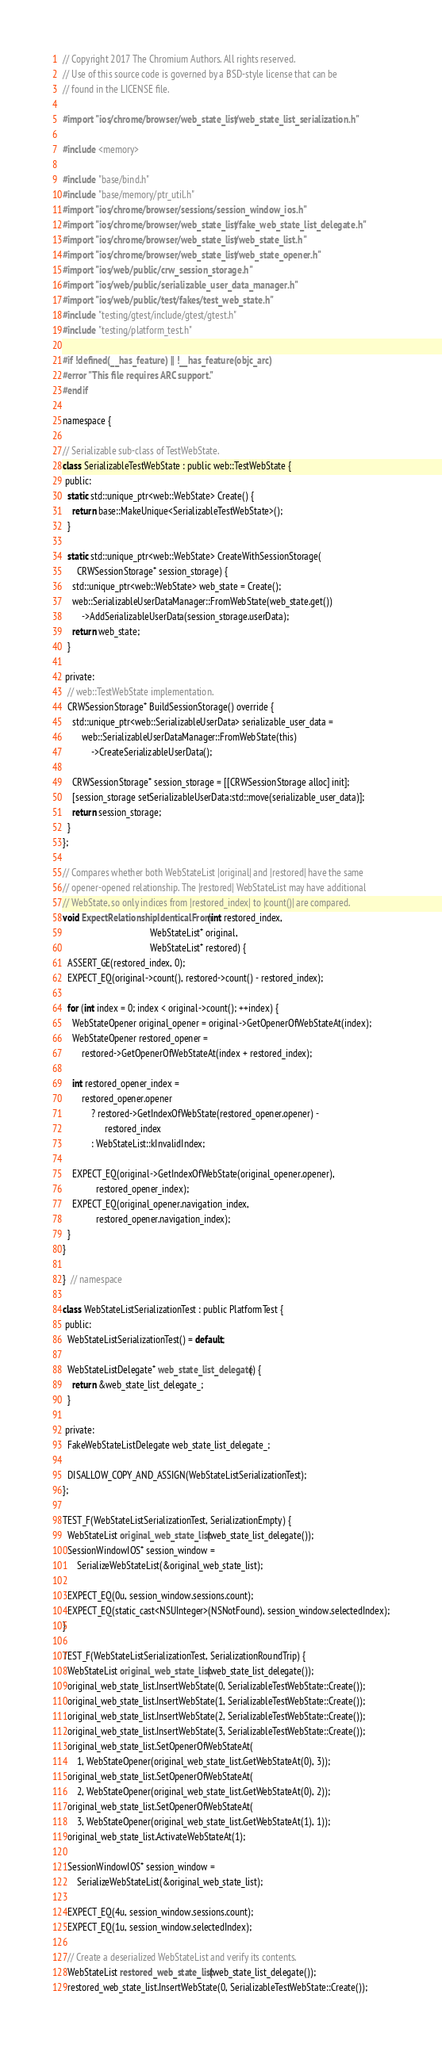Convert code to text. <code><loc_0><loc_0><loc_500><loc_500><_ObjectiveC_>// Copyright 2017 The Chromium Authors. All rights reserved.
// Use of this source code is governed by a BSD-style license that can be
// found in the LICENSE file.

#import "ios/chrome/browser/web_state_list/web_state_list_serialization.h"

#include <memory>

#include "base/bind.h"
#include "base/memory/ptr_util.h"
#import "ios/chrome/browser/sessions/session_window_ios.h"
#import "ios/chrome/browser/web_state_list/fake_web_state_list_delegate.h"
#import "ios/chrome/browser/web_state_list/web_state_list.h"
#import "ios/chrome/browser/web_state_list/web_state_opener.h"
#import "ios/web/public/crw_session_storage.h"
#import "ios/web/public/serializable_user_data_manager.h"
#import "ios/web/public/test/fakes/test_web_state.h"
#include "testing/gtest/include/gtest/gtest.h"
#include "testing/platform_test.h"

#if !defined(__has_feature) || !__has_feature(objc_arc)
#error "This file requires ARC support."
#endif

namespace {

// Serializable sub-class of TestWebState.
class SerializableTestWebState : public web::TestWebState {
 public:
  static std::unique_ptr<web::WebState> Create() {
    return base::MakeUnique<SerializableTestWebState>();
  }

  static std::unique_ptr<web::WebState> CreateWithSessionStorage(
      CRWSessionStorage* session_storage) {
    std::unique_ptr<web::WebState> web_state = Create();
    web::SerializableUserDataManager::FromWebState(web_state.get())
        ->AddSerializableUserData(session_storage.userData);
    return web_state;
  }

 private:
  // web::TestWebState implementation.
  CRWSessionStorage* BuildSessionStorage() override {
    std::unique_ptr<web::SerializableUserData> serializable_user_data =
        web::SerializableUserDataManager::FromWebState(this)
            ->CreateSerializableUserData();

    CRWSessionStorage* session_storage = [[CRWSessionStorage alloc] init];
    [session_storage setSerializableUserData:std::move(serializable_user_data)];
    return session_storage;
  }
};

// Compares whether both WebStateList |original| and |restored| have the same
// opener-opened relationship. The |restored| WebStateList may have additional
// WebState, so only indices from |restored_index| to |count()| are compared.
void ExpectRelationshipIdenticalFrom(int restored_index,
                                     WebStateList* original,
                                     WebStateList* restored) {
  ASSERT_GE(restored_index, 0);
  EXPECT_EQ(original->count(), restored->count() - restored_index);

  for (int index = 0; index < original->count(); ++index) {
    WebStateOpener original_opener = original->GetOpenerOfWebStateAt(index);
    WebStateOpener restored_opener =
        restored->GetOpenerOfWebStateAt(index + restored_index);

    int restored_opener_index =
        restored_opener.opener
            ? restored->GetIndexOfWebState(restored_opener.opener) -
                  restored_index
            : WebStateList::kInvalidIndex;

    EXPECT_EQ(original->GetIndexOfWebState(original_opener.opener),
              restored_opener_index);
    EXPECT_EQ(original_opener.navigation_index,
              restored_opener.navigation_index);
  }
}

}  // namespace

class WebStateListSerializationTest : public PlatformTest {
 public:
  WebStateListSerializationTest() = default;

  WebStateListDelegate* web_state_list_delegate() {
    return &web_state_list_delegate_;
  }

 private:
  FakeWebStateListDelegate web_state_list_delegate_;

  DISALLOW_COPY_AND_ASSIGN(WebStateListSerializationTest);
};

TEST_F(WebStateListSerializationTest, SerializationEmpty) {
  WebStateList original_web_state_list(web_state_list_delegate());
  SessionWindowIOS* session_window =
      SerializeWebStateList(&original_web_state_list);

  EXPECT_EQ(0u, session_window.sessions.count);
  EXPECT_EQ(static_cast<NSUInteger>(NSNotFound), session_window.selectedIndex);
}

TEST_F(WebStateListSerializationTest, SerializationRoundTrip) {
  WebStateList original_web_state_list(web_state_list_delegate());
  original_web_state_list.InsertWebState(0, SerializableTestWebState::Create());
  original_web_state_list.InsertWebState(1, SerializableTestWebState::Create());
  original_web_state_list.InsertWebState(2, SerializableTestWebState::Create());
  original_web_state_list.InsertWebState(3, SerializableTestWebState::Create());
  original_web_state_list.SetOpenerOfWebStateAt(
      1, WebStateOpener(original_web_state_list.GetWebStateAt(0), 3));
  original_web_state_list.SetOpenerOfWebStateAt(
      2, WebStateOpener(original_web_state_list.GetWebStateAt(0), 2));
  original_web_state_list.SetOpenerOfWebStateAt(
      3, WebStateOpener(original_web_state_list.GetWebStateAt(1), 1));
  original_web_state_list.ActivateWebStateAt(1);

  SessionWindowIOS* session_window =
      SerializeWebStateList(&original_web_state_list);

  EXPECT_EQ(4u, session_window.sessions.count);
  EXPECT_EQ(1u, session_window.selectedIndex);

  // Create a deserialized WebStateList and verify its contents.
  WebStateList restored_web_state_list(web_state_list_delegate());
  restored_web_state_list.InsertWebState(0, SerializableTestWebState::Create());</code> 